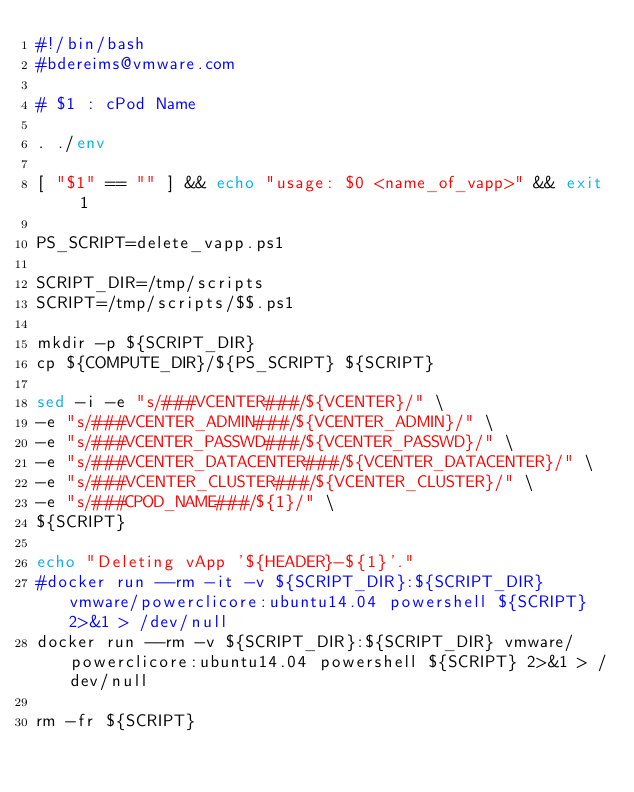Convert code to text. <code><loc_0><loc_0><loc_500><loc_500><_Bash_>#!/bin/bash
#bdereims@vmware.com

# $1 : cPod Name

. ./env

[ "$1" == "" ] && echo "usage: $0 <name_of_vapp>" && exit 1 

PS_SCRIPT=delete_vapp.ps1

SCRIPT_DIR=/tmp/scripts
SCRIPT=/tmp/scripts/$$.ps1

mkdir -p ${SCRIPT_DIR} 
cp ${COMPUTE_DIR}/${PS_SCRIPT} ${SCRIPT} 

sed -i -e "s/###VCENTER###/${VCENTER}/" \
-e "s/###VCENTER_ADMIN###/${VCENTER_ADMIN}/" \
-e "s/###VCENTER_PASSWD###/${VCENTER_PASSWD}/" \
-e "s/###VCENTER_DATACENTER###/${VCENTER_DATACENTER}/" \
-e "s/###VCENTER_CLUSTER###/${VCENTER_CLUSTER}/" \
-e "s/###CPOD_NAME###/${1}/" \
${SCRIPT}

echo "Deleting vApp '${HEADER}-${1}'."
#docker run --rm -it -v ${SCRIPT_DIR}:${SCRIPT_DIR} vmware/powerclicore:ubuntu14.04 powershell ${SCRIPT} 2>&1 > /dev/null
docker run --rm -v ${SCRIPT_DIR}:${SCRIPT_DIR} vmware/powerclicore:ubuntu14.04 powershell ${SCRIPT} 2>&1 > /dev/null

rm -fr ${SCRIPT}
</code> 